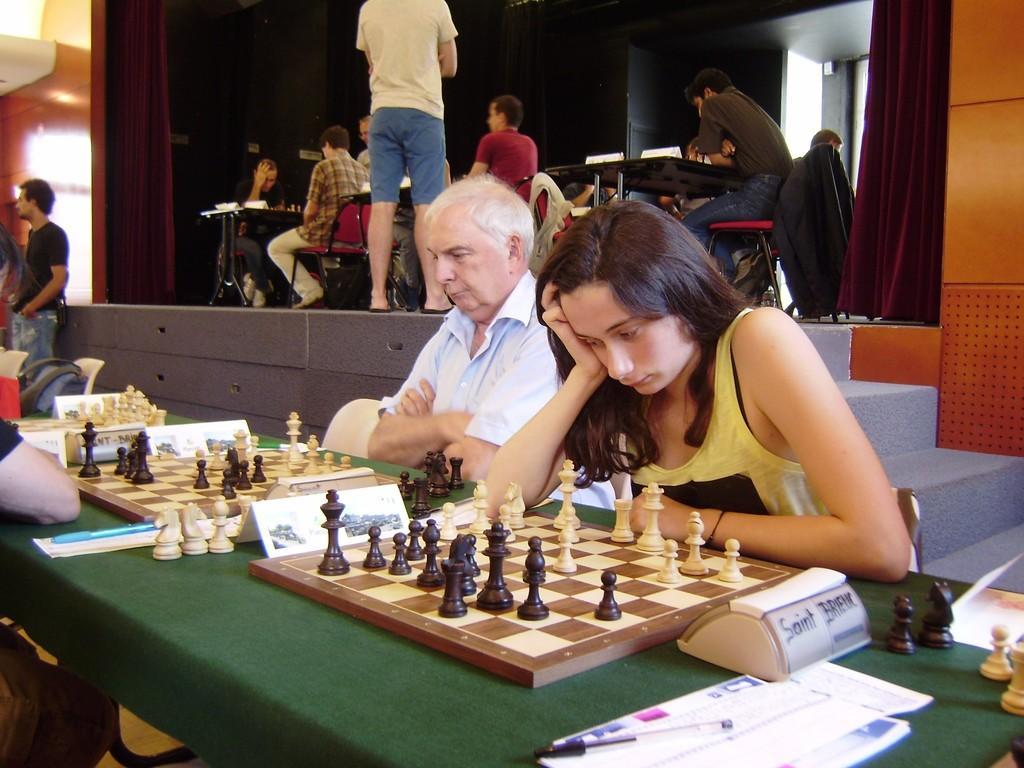In one or two sentences, can you explain what this image depicts? In this image I see 3 persons and they are sitting on the chairs and there is a table in front of them and there is a chess board and few chess coins on it. In the background I see few people who are sitting on the chairs and there are tables over there too. 